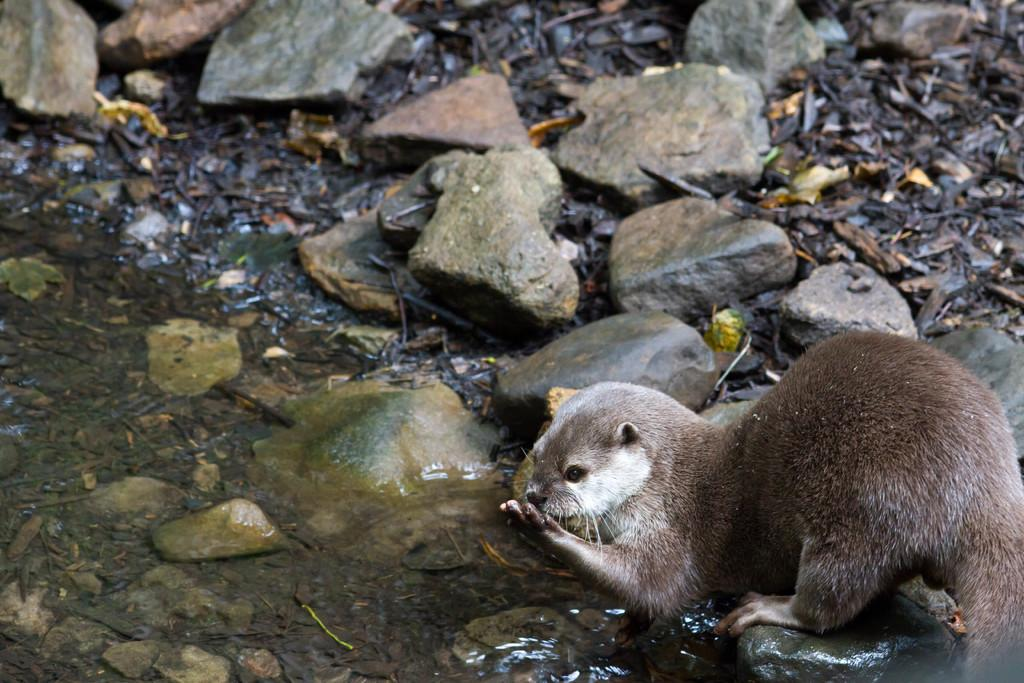What is present at the bottom of the image? There is water at the bottom of the image. What animal can be seen in the image? There is an otter in the image. What type of terrain is visible in the image? There are rocks and dried leaves on the ground in the image. What type of tool is the squirrel using to break open the rocks in the image? There is no squirrel present in the image, and no rocks are being broken open. 